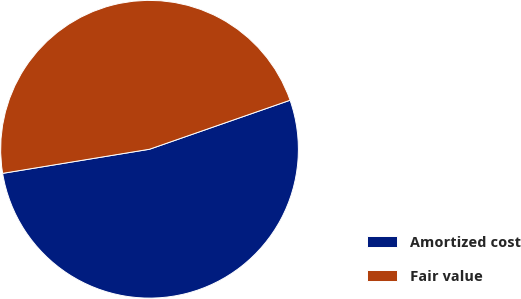Convert chart. <chart><loc_0><loc_0><loc_500><loc_500><pie_chart><fcel>Amortized cost<fcel>Fair value<nl><fcel>52.75%<fcel>47.25%<nl></chart> 